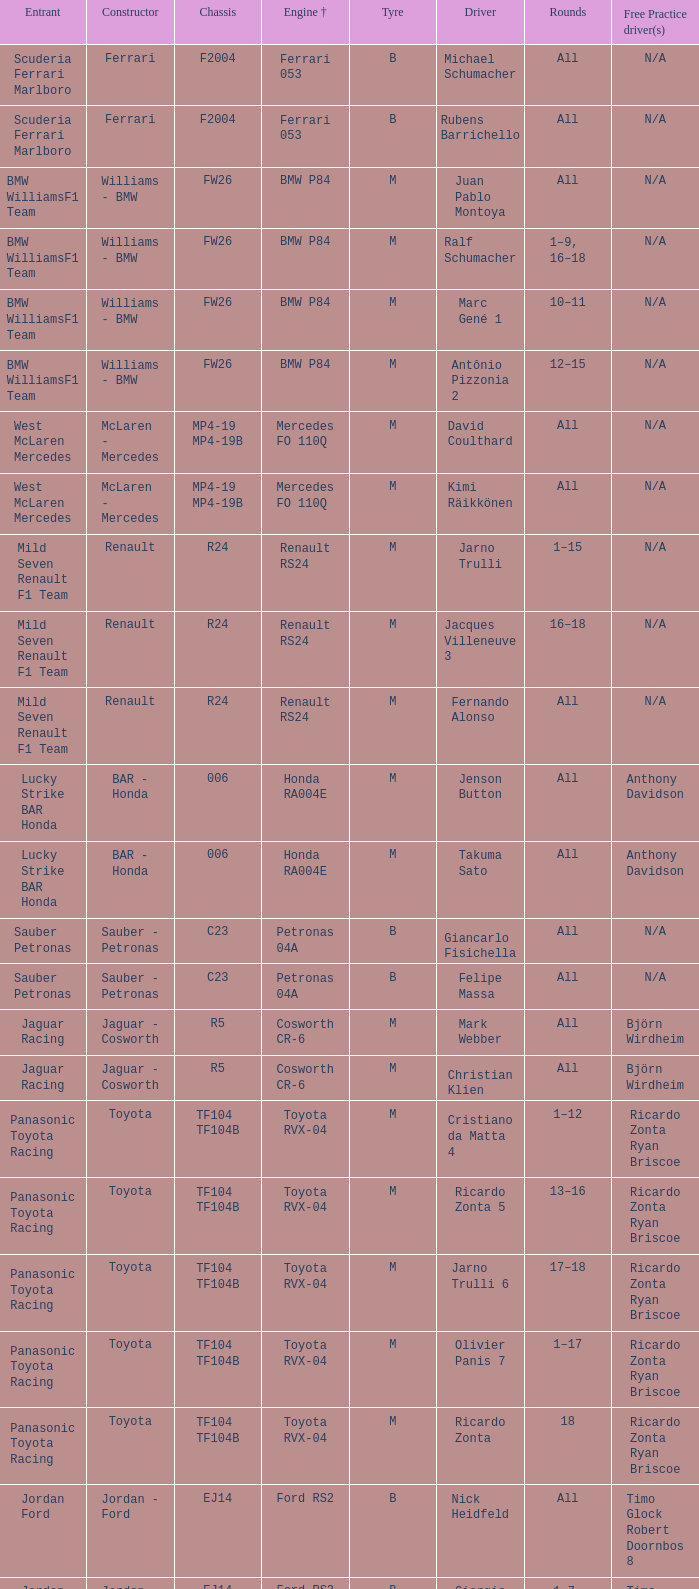What are the rounds for the B tyres and Ferrari 053 engine +? All, All. 